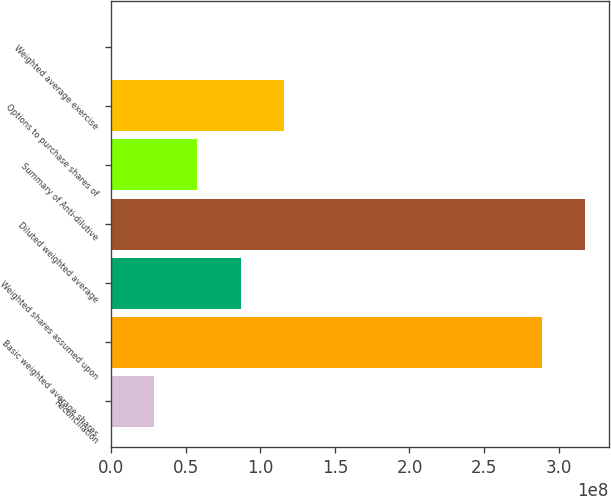Convert chart. <chart><loc_0><loc_0><loc_500><loc_500><bar_chart><fcel>Reconciliation<fcel>Basic weighted average shares<fcel>Weighted shares assumed upon<fcel>Diluted weighted average<fcel>Summary of Anti-dilutive<fcel>Options to purchase shares of<fcel>Weighted average exercise<nl><fcel>2.89158e+07<fcel>2.8895e+08<fcel>8.67473e+07<fcel>3.17865e+08<fcel>5.78315e+07<fcel>1.15663e+08<fcel>50.09<nl></chart> 